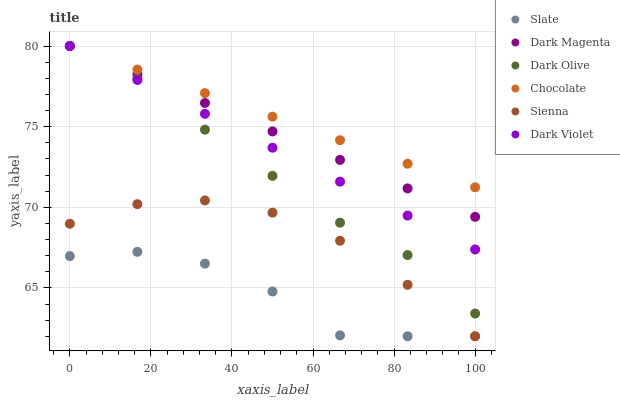Does Slate have the minimum area under the curve?
Answer yes or no. Yes. Does Chocolate have the maximum area under the curve?
Answer yes or no. Yes. Does Dark Olive have the minimum area under the curve?
Answer yes or no. No. Does Dark Olive have the maximum area under the curve?
Answer yes or no. No. Is Dark Violet the smoothest?
Answer yes or no. Yes. Is Slate the roughest?
Answer yes or no. Yes. Is Dark Olive the smoothest?
Answer yes or no. No. Is Dark Olive the roughest?
Answer yes or no. No. Does Slate have the lowest value?
Answer yes or no. Yes. Does Dark Olive have the lowest value?
Answer yes or no. No. Does Chocolate have the highest value?
Answer yes or no. Yes. Does Slate have the highest value?
Answer yes or no. No. Is Sienna less than Dark Olive?
Answer yes or no. Yes. Is Chocolate greater than Sienna?
Answer yes or no. Yes. Does Dark Violet intersect Dark Olive?
Answer yes or no. Yes. Is Dark Violet less than Dark Olive?
Answer yes or no. No. Is Dark Violet greater than Dark Olive?
Answer yes or no. No. Does Sienna intersect Dark Olive?
Answer yes or no. No. 